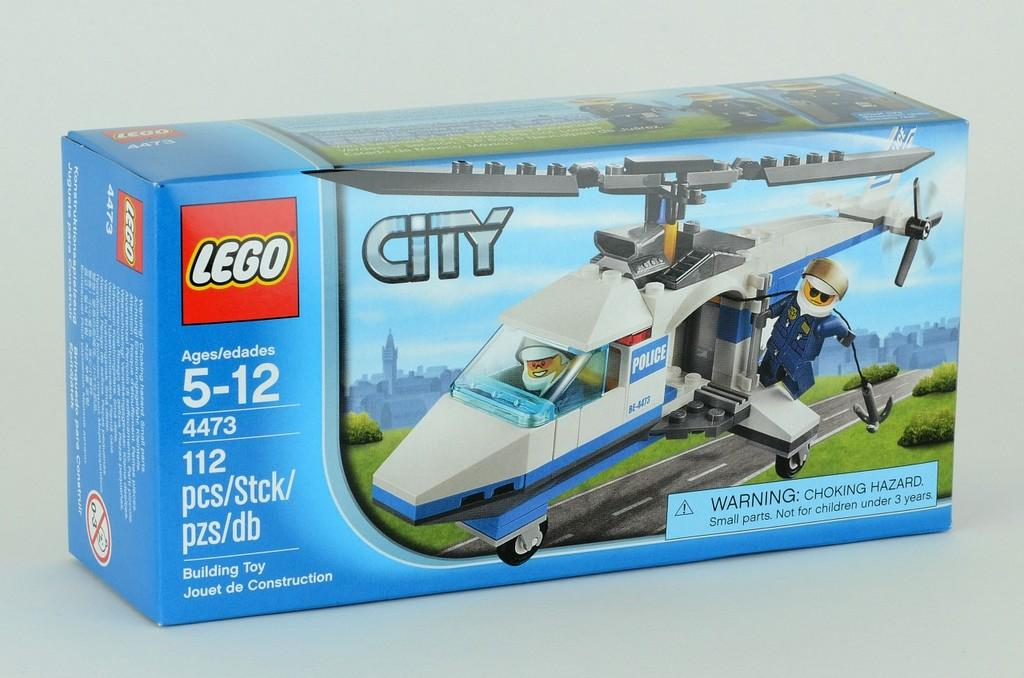<image>
Share a concise interpretation of the image provided. The Lego logo is on a box for a toy. 